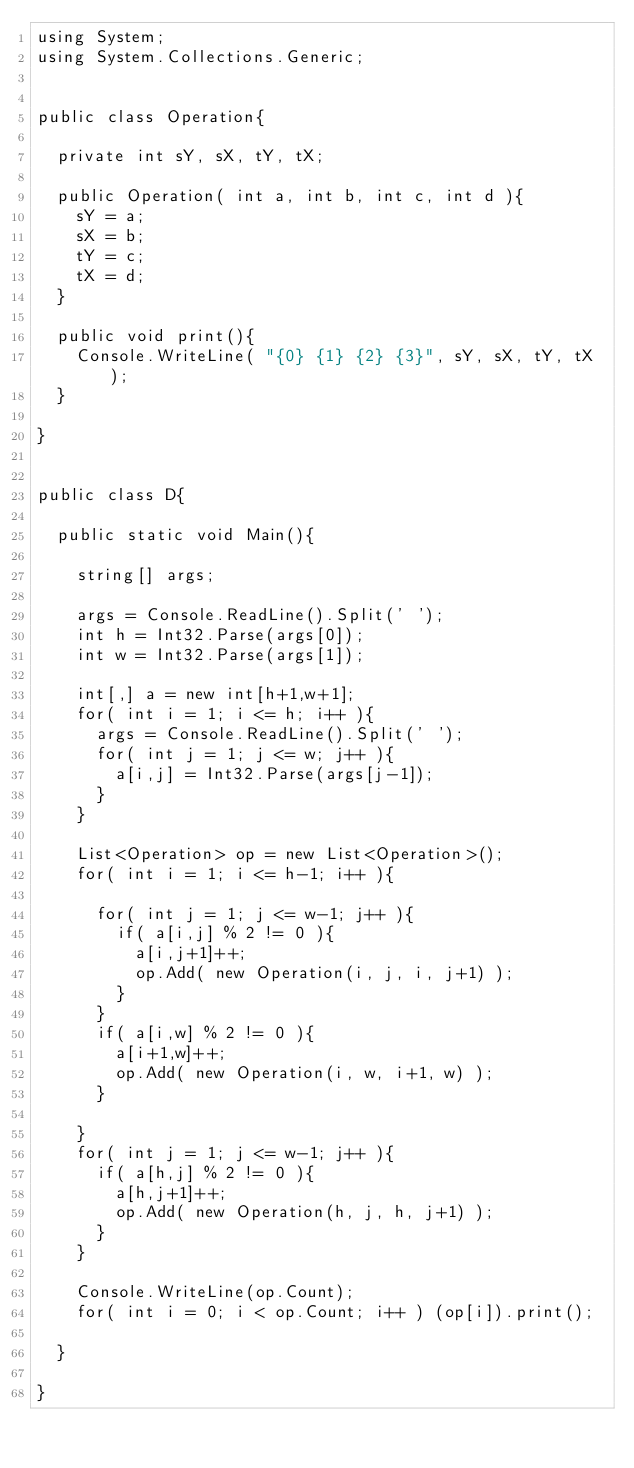<code> <loc_0><loc_0><loc_500><loc_500><_C#_>using System;
using System.Collections.Generic;


public class Operation{

	private int sY, sX, tY, tX;
	
	public Operation( int a, int b, int c, int d ){
		sY = a;
		sX = b;
		tY = c;
		tX = d;		
	}
	
	public void print(){
		Console.WriteLine( "{0} {1} {2} {3}", sY, sX, tY, tX );
	}
	
}


public class D{
	
	public static void Main(){
	
		string[] args;
		
		args = Console.ReadLine().Split(' ');
		int h = Int32.Parse(args[0]);
		int w = Int32.Parse(args[1]);
		
		int[,] a = new int[h+1,w+1];
		for( int i = 1; i <= h; i++ ){
			args = Console.ReadLine().Split(' ');
			for( int j = 1; j <= w; j++ ){
				a[i,j] = Int32.Parse(args[j-1]);
			}
		}
		
		List<Operation> op = new List<Operation>();
		for( int i = 1; i <= h-1; i++ ){
			
			for( int j = 1; j <= w-1; j++ ){
				if( a[i,j] % 2 != 0 ){
					a[i,j+1]++;
					op.Add( new Operation(i, j, i, j+1) );
				}
			}
			if( a[i,w] % 2 != 0 ){
				a[i+1,w]++;
				op.Add( new Operation(i, w, i+1, w) );
			}
			
		}
		for( int j = 1; j <= w-1; j++ ){
			if( a[h,j] % 2 != 0 ){
				a[h,j+1]++;
				op.Add( new Operation(h, j, h, j+1) );
			}	
		}
		
		Console.WriteLine(op.Count);
		for( int i = 0; i < op.Count; i++ ) (op[i]).print();

	}

}</code> 